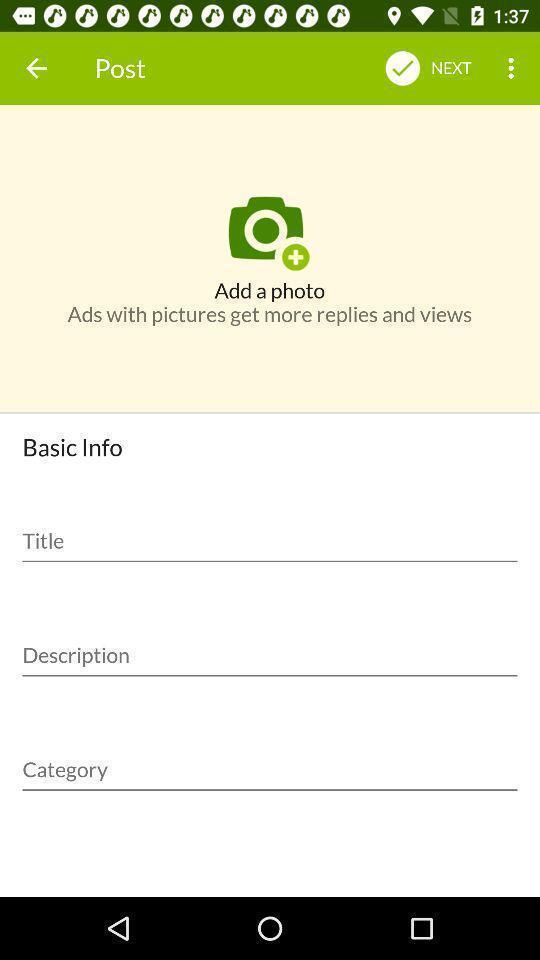Summarize the information in this screenshot. Screen showing basic info page. 